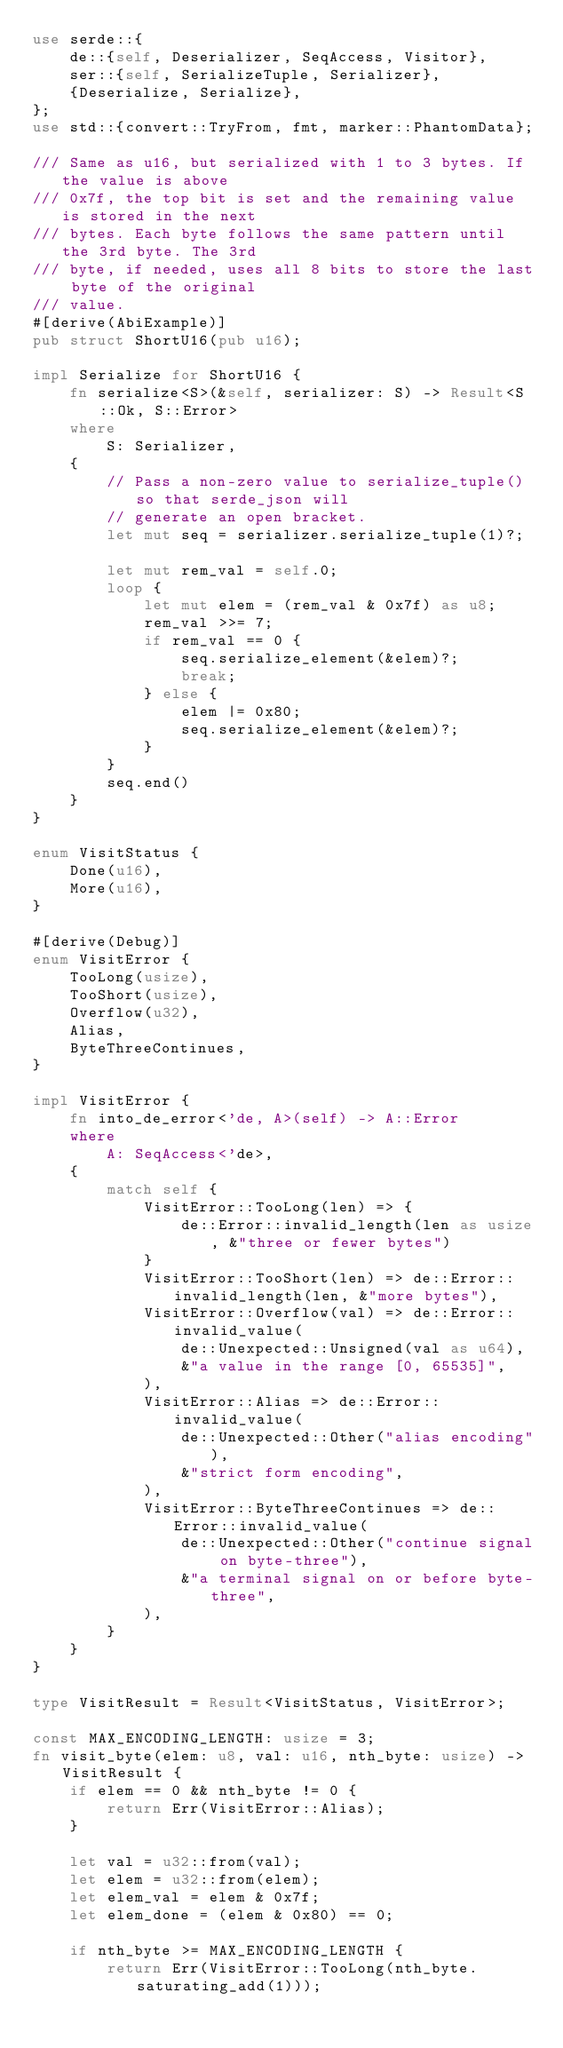<code> <loc_0><loc_0><loc_500><loc_500><_Rust_>use serde::{
    de::{self, Deserializer, SeqAccess, Visitor},
    ser::{self, SerializeTuple, Serializer},
    {Deserialize, Serialize},
};
use std::{convert::TryFrom, fmt, marker::PhantomData};

/// Same as u16, but serialized with 1 to 3 bytes. If the value is above
/// 0x7f, the top bit is set and the remaining value is stored in the next
/// bytes. Each byte follows the same pattern until the 3rd byte. The 3rd
/// byte, if needed, uses all 8 bits to store the last byte of the original
/// value.
#[derive(AbiExample)]
pub struct ShortU16(pub u16);

impl Serialize for ShortU16 {
    fn serialize<S>(&self, serializer: S) -> Result<S::Ok, S::Error>
    where
        S: Serializer,
    {
        // Pass a non-zero value to serialize_tuple() so that serde_json will
        // generate an open bracket.
        let mut seq = serializer.serialize_tuple(1)?;

        let mut rem_val = self.0;
        loop {
            let mut elem = (rem_val & 0x7f) as u8;
            rem_val >>= 7;
            if rem_val == 0 {
                seq.serialize_element(&elem)?;
                break;
            } else {
                elem |= 0x80;
                seq.serialize_element(&elem)?;
            }
        }
        seq.end()
    }
}

enum VisitStatus {
    Done(u16),
    More(u16),
}

#[derive(Debug)]
enum VisitError {
    TooLong(usize),
    TooShort(usize),
    Overflow(u32),
    Alias,
    ByteThreeContinues,
}

impl VisitError {
    fn into_de_error<'de, A>(self) -> A::Error
    where
        A: SeqAccess<'de>,
    {
        match self {
            VisitError::TooLong(len) => {
                de::Error::invalid_length(len as usize, &"three or fewer bytes")
            }
            VisitError::TooShort(len) => de::Error::invalid_length(len, &"more bytes"),
            VisitError::Overflow(val) => de::Error::invalid_value(
                de::Unexpected::Unsigned(val as u64),
                &"a value in the range [0, 65535]",
            ),
            VisitError::Alias => de::Error::invalid_value(
                de::Unexpected::Other("alias encoding"),
                &"strict form encoding",
            ),
            VisitError::ByteThreeContinues => de::Error::invalid_value(
                de::Unexpected::Other("continue signal on byte-three"),
                &"a terminal signal on or before byte-three",
            ),
        }
    }
}

type VisitResult = Result<VisitStatus, VisitError>;

const MAX_ENCODING_LENGTH: usize = 3;
fn visit_byte(elem: u8, val: u16, nth_byte: usize) -> VisitResult {
    if elem == 0 && nth_byte != 0 {
        return Err(VisitError::Alias);
    }

    let val = u32::from(val);
    let elem = u32::from(elem);
    let elem_val = elem & 0x7f;
    let elem_done = (elem & 0x80) == 0;

    if nth_byte >= MAX_ENCODING_LENGTH {
        return Err(VisitError::TooLong(nth_byte.saturating_add(1)));</code> 